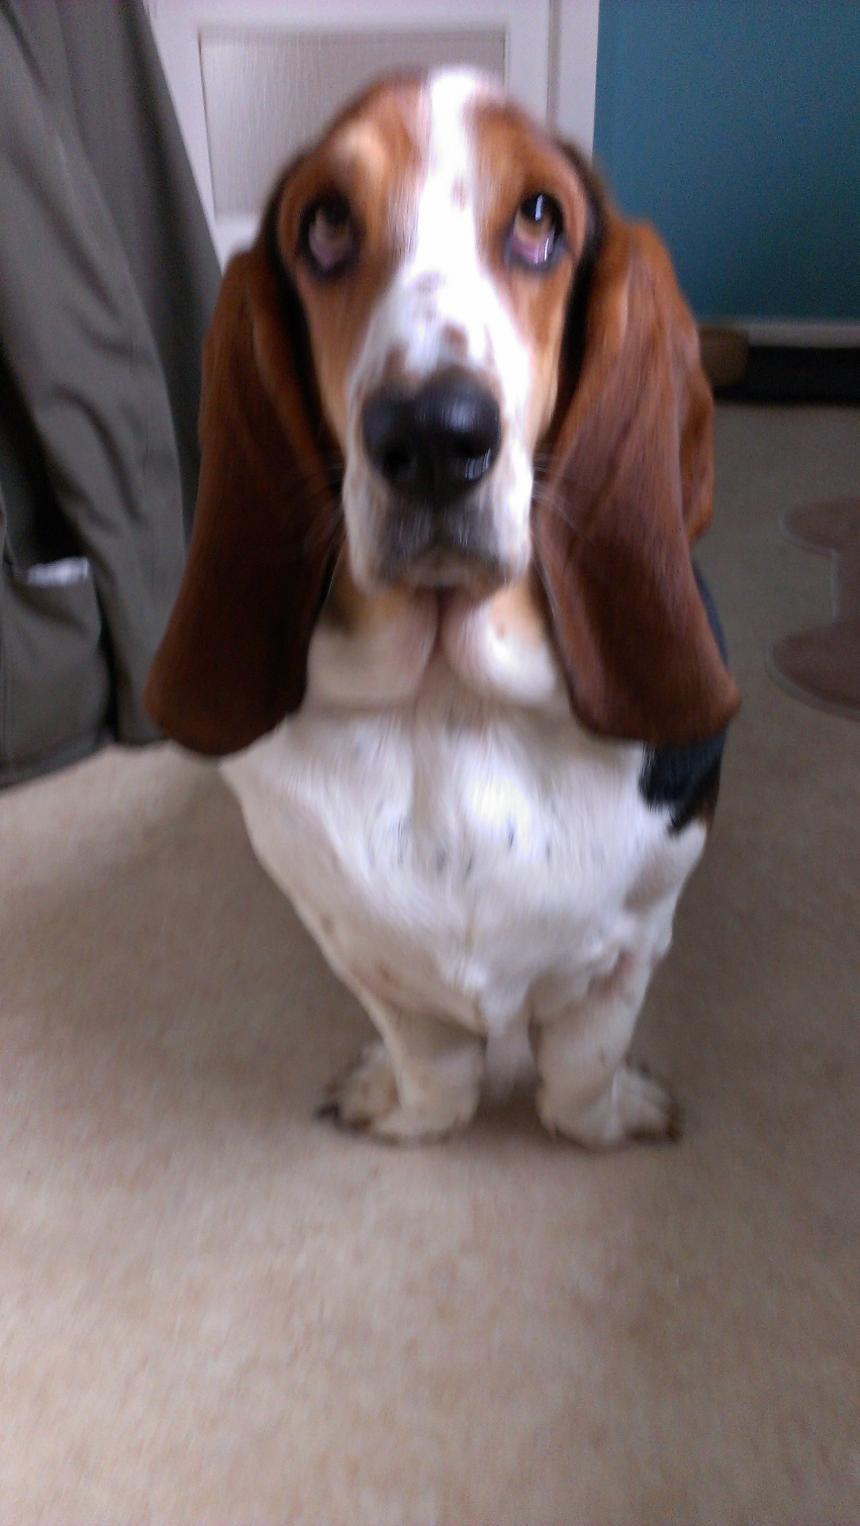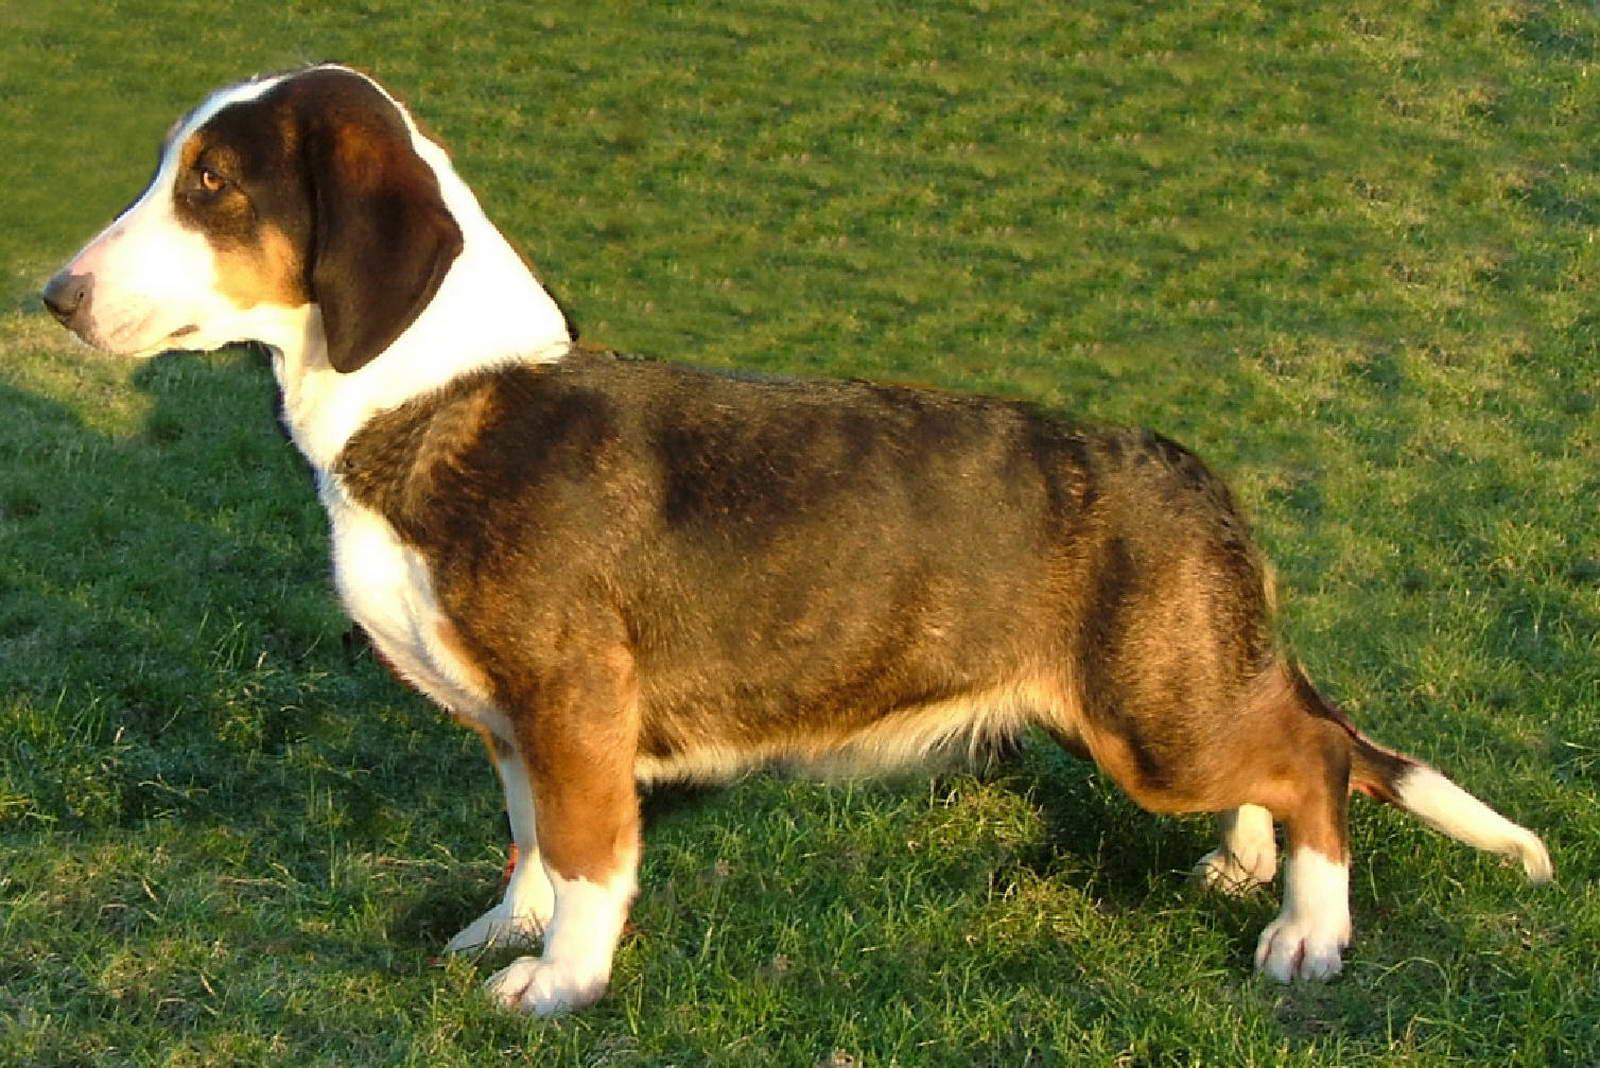The first image is the image on the left, the second image is the image on the right. Considering the images on both sides, is "a dog is standing in the grass facing left'" valid? Answer yes or no. Yes. The first image is the image on the left, the second image is the image on the right. Analyze the images presented: Is the assertion "At least one dog is standing on the grass." valid? Answer yes or no. Yes. 